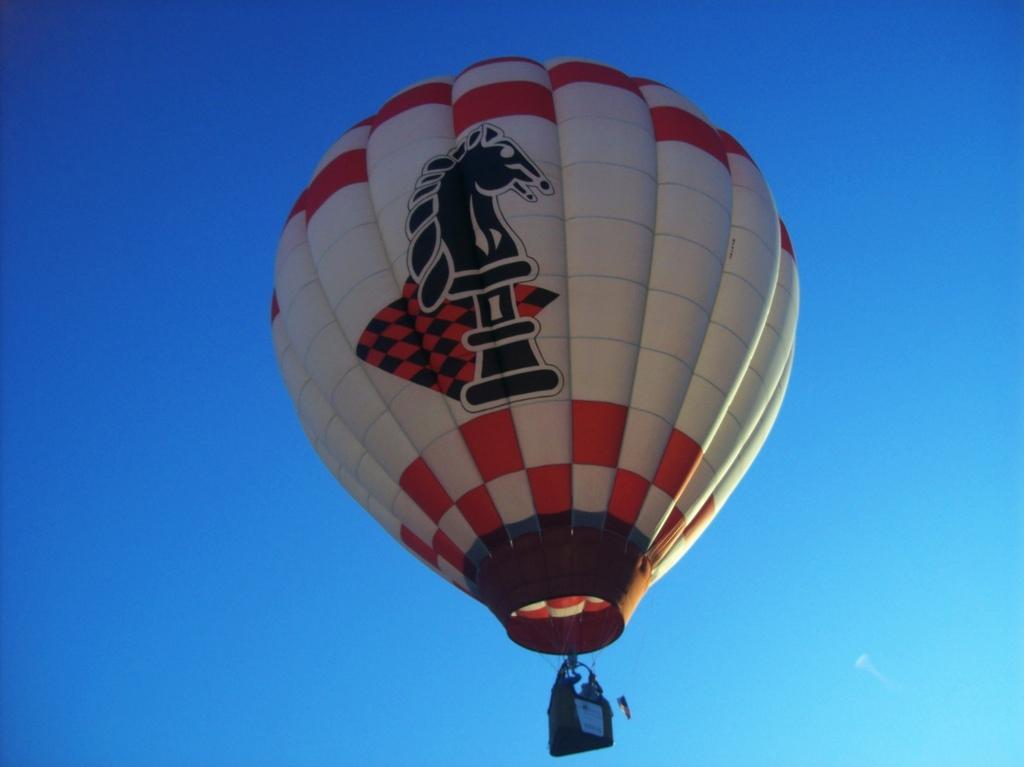How would you summarize this image in a sentence or two? In this image there is a hot air balloon, at the background of the image there is the blue sky. 